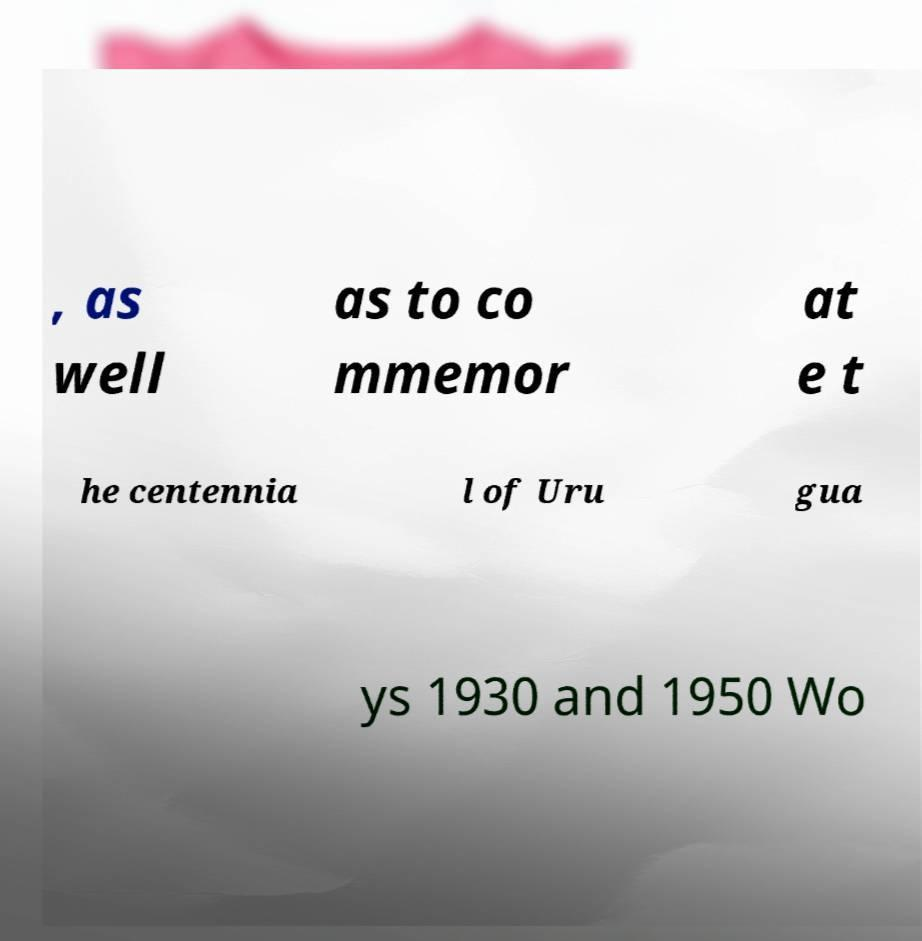Could you extract and type out the text from this image? , as well as to co mmemor at e t he centennia l of Uru gua ys 1930 and 1950 Wo 